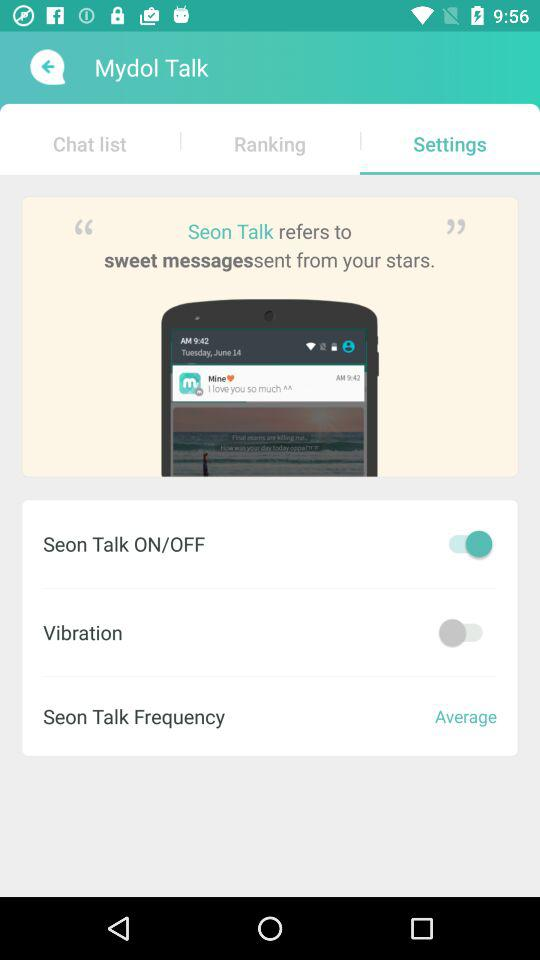What setting is disabled? The setting is "Vibration". 